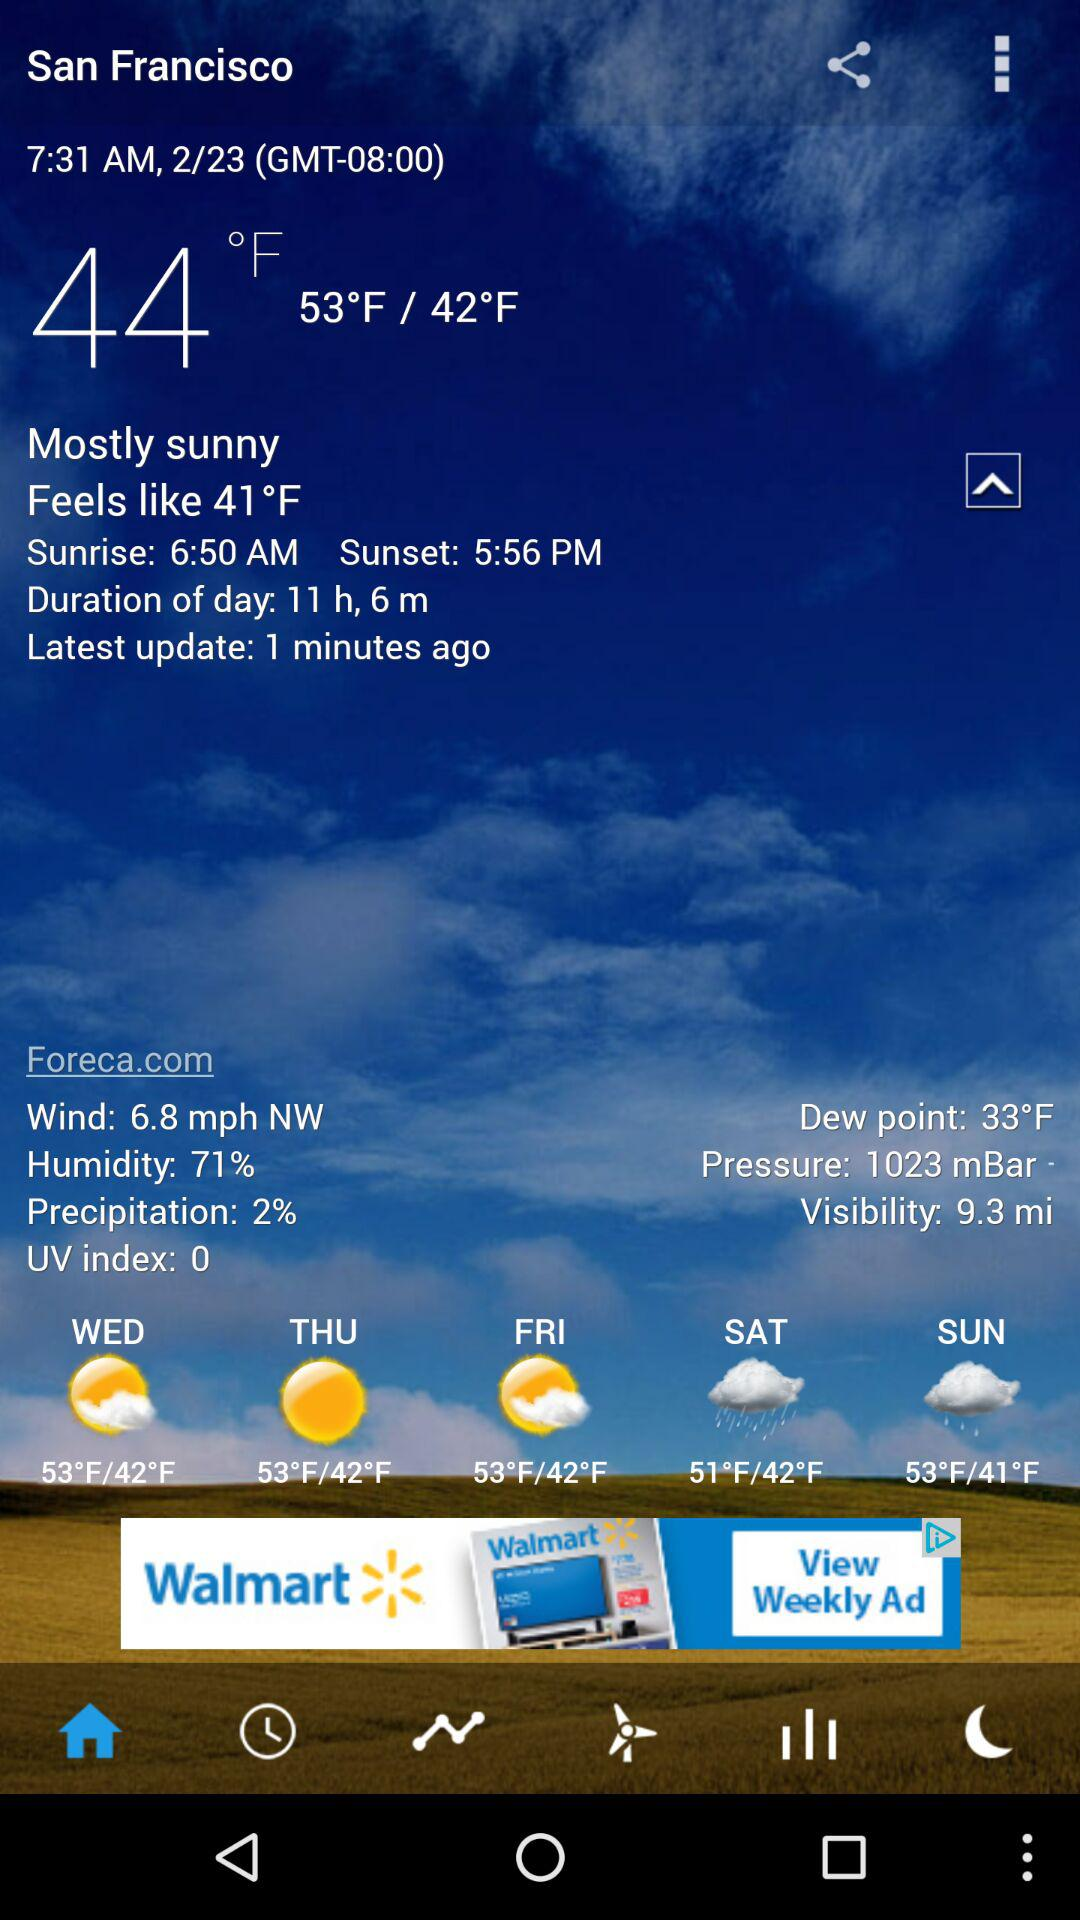What is the duration of the day? The duration of the day is 11 hours and 6 minutes. 